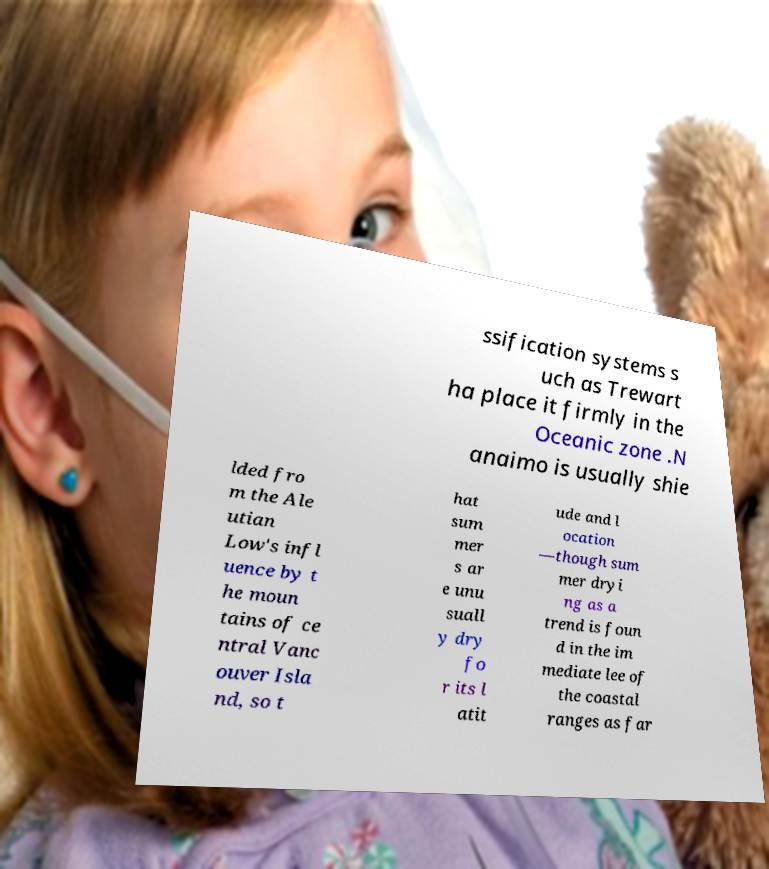I need the written content from this picture converted into text. Can you do that? ssification systems s uch as Trewart ha place it firmly in the Oceanic zone .N anaimo is usually shie lded fro m the Ale utian Low's infl uence by t he moun tains of ce ntral Vanc ouver Isla nd, so t hat sum mer s ar e unu suall y dry fo r its l atit ude and l ocation —though sum mer dryi ng as a trend is foun d in the im mediate lee of the coastal ranges as far 